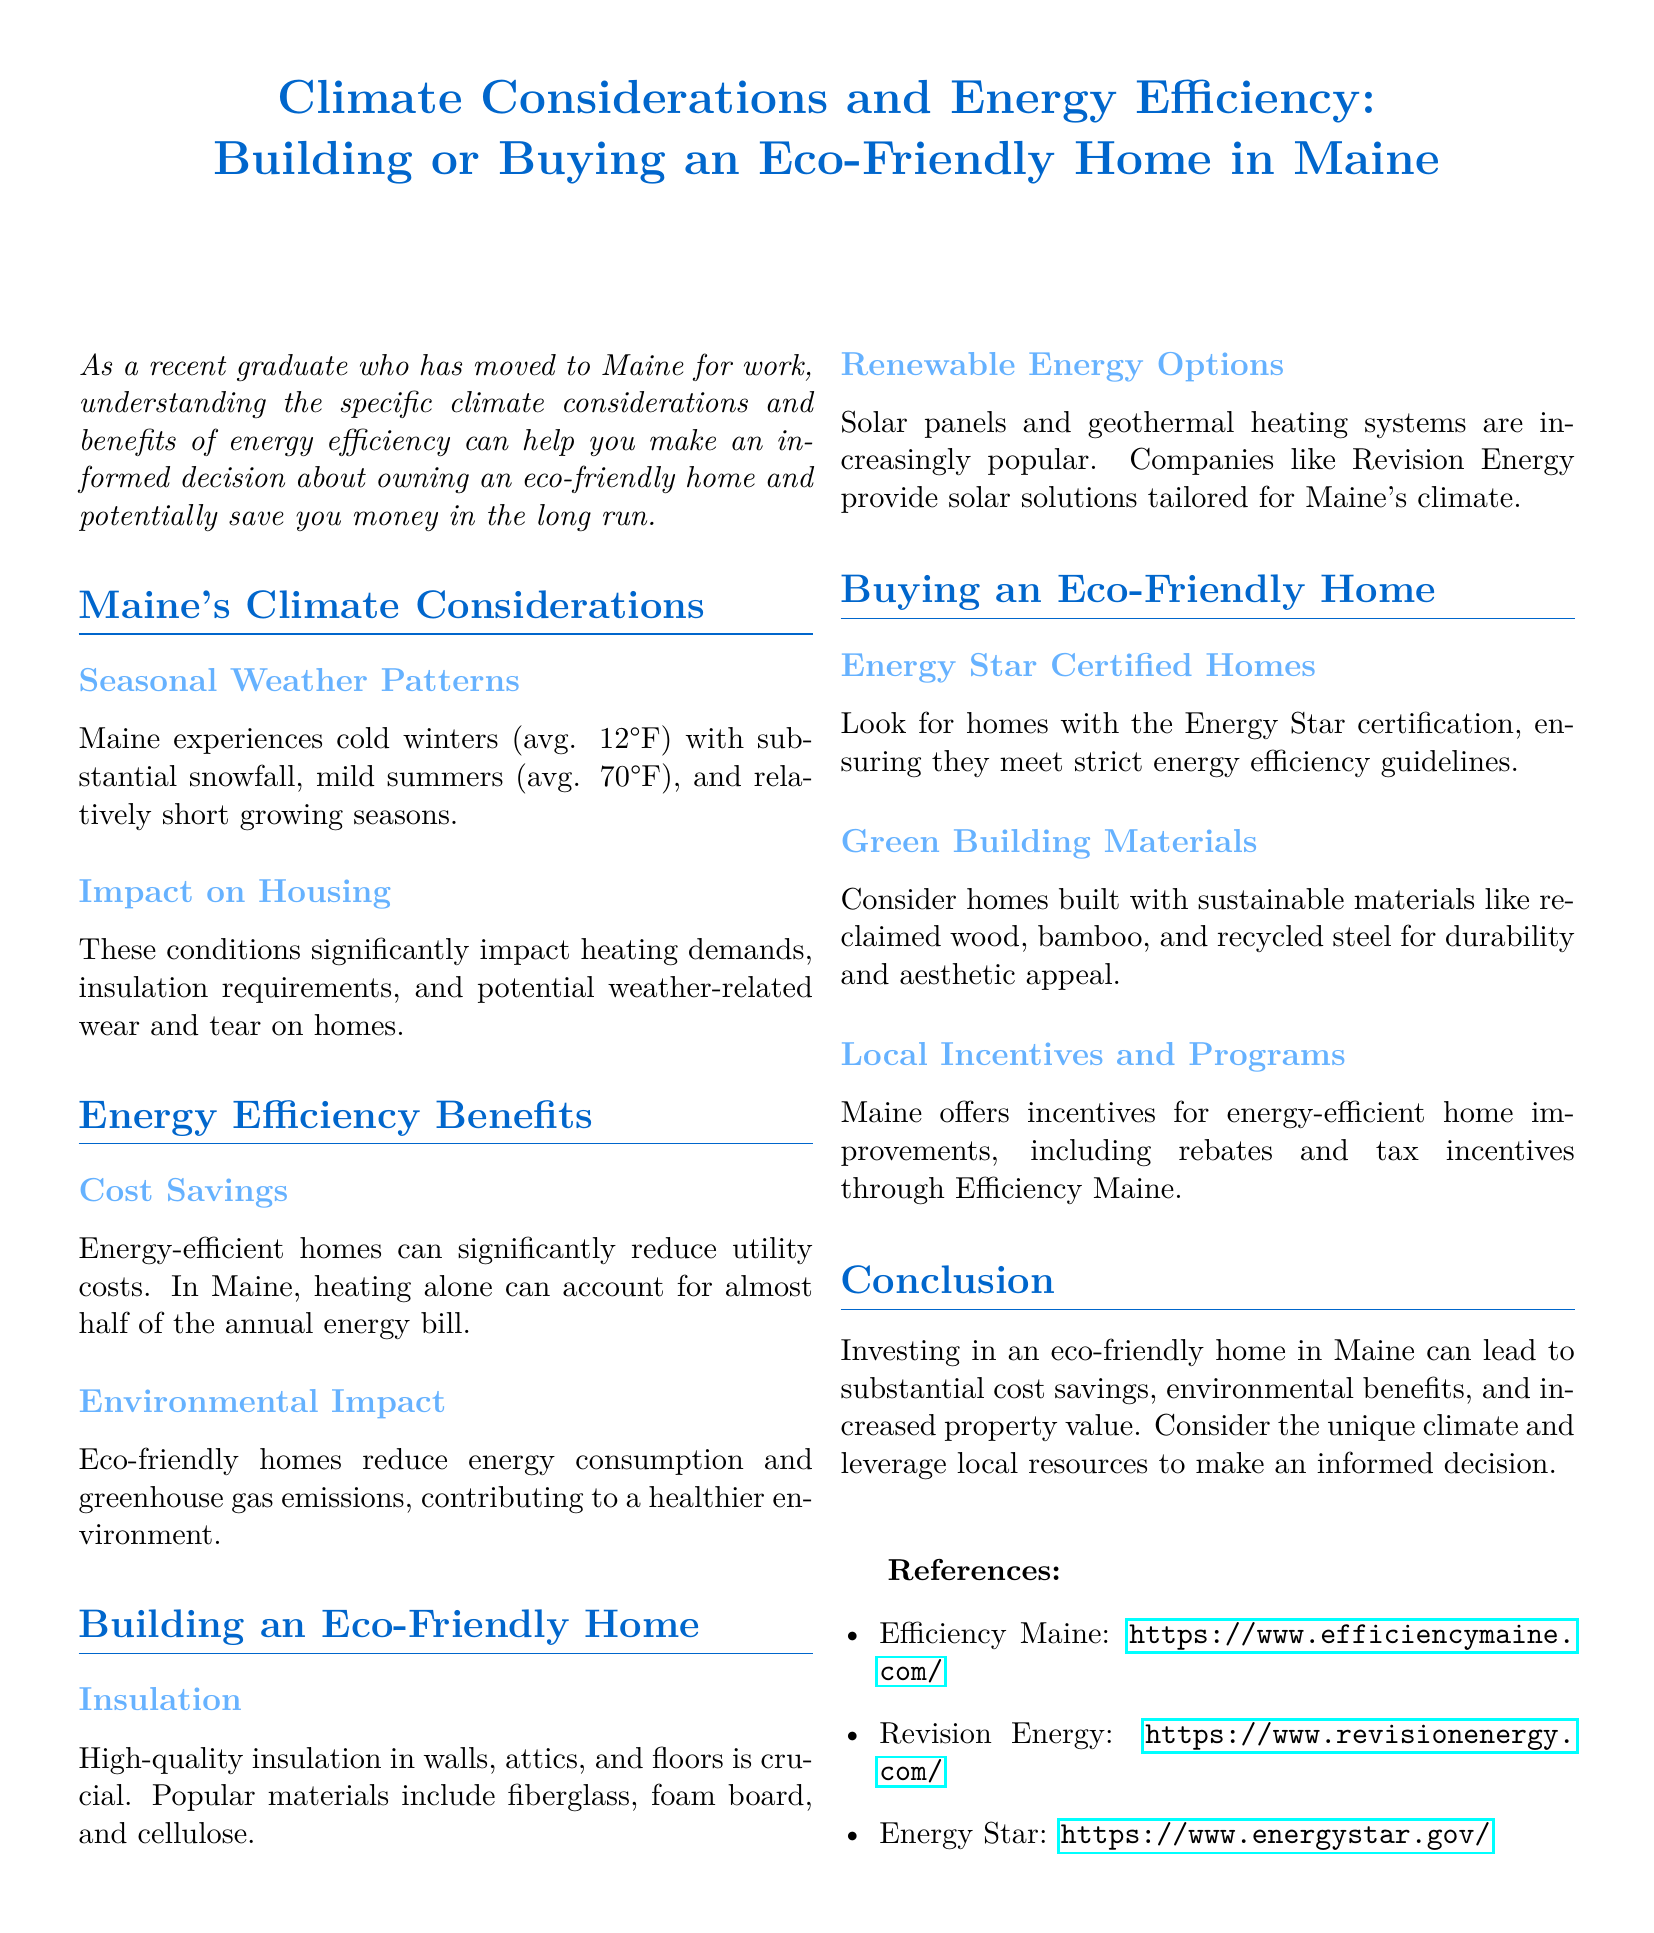What is the average winter temperature in Maine? The document states that Maine experiences cold winters with an average temperature of 12°F.
Answer: 12°F What percentage of the annual energy bill can heating account for in Maine? According to the document, heating can account for almost half of the annual energy bill in Maine.
Answer: Almost half What renewable energy options are mentioned for building eco-friendly homes? The document lists solar panels and geothermal heating systems as popular renewable energy options in Maine.
Answer: Solar panels and geothermal heating systems What certification should you look for when buying an eco-friendly home? The document advises looking for homes with the Energy Star certification to ensure energy efficiency.
Answer: Energy Star certification What materials are recommended for insulation in eco-friendly homes? The document mentions fiberglass, foam board, and cellulose as popular materials for insulation.
Answer: Fiberglass, foam board, and cellulose What local program is mentioned that offers incentives for energy-efficient home improvements? The document refers to Efficiency Maine as a source of rebates and tax incentives.
Answer: Efficiency Maine What environmental benefit is associated with eco-friendly homes? The document states that eco-friendly homes reduce greenhouse gas emissions, contributing to a healthier environment.
Answer: Reduce greenhouse gas emissions What are two sustainable building materials suggested in the document? The document suggests reclaimed wood and bamboo as sustainable building materials for durability and aesthetic appeal.
Answer: Reclaimed wood and bamboo 